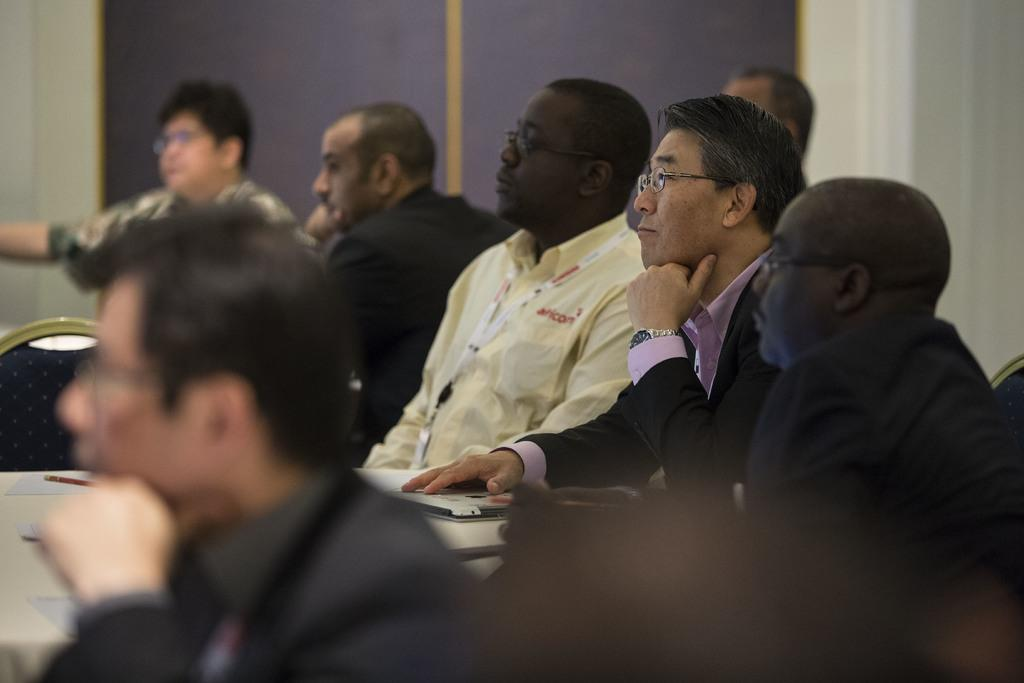What are the people in the image doing? The people in the image are sitting in front of a table. What can be seen on the table? There are objects on the table. What is visible in the background of the image? There is a wall in the background of the image. What type of ornament is hanging from the ceiling in the image? There is no ornament hanging from the ceiling in the image; only the people, table, and wall are present. 